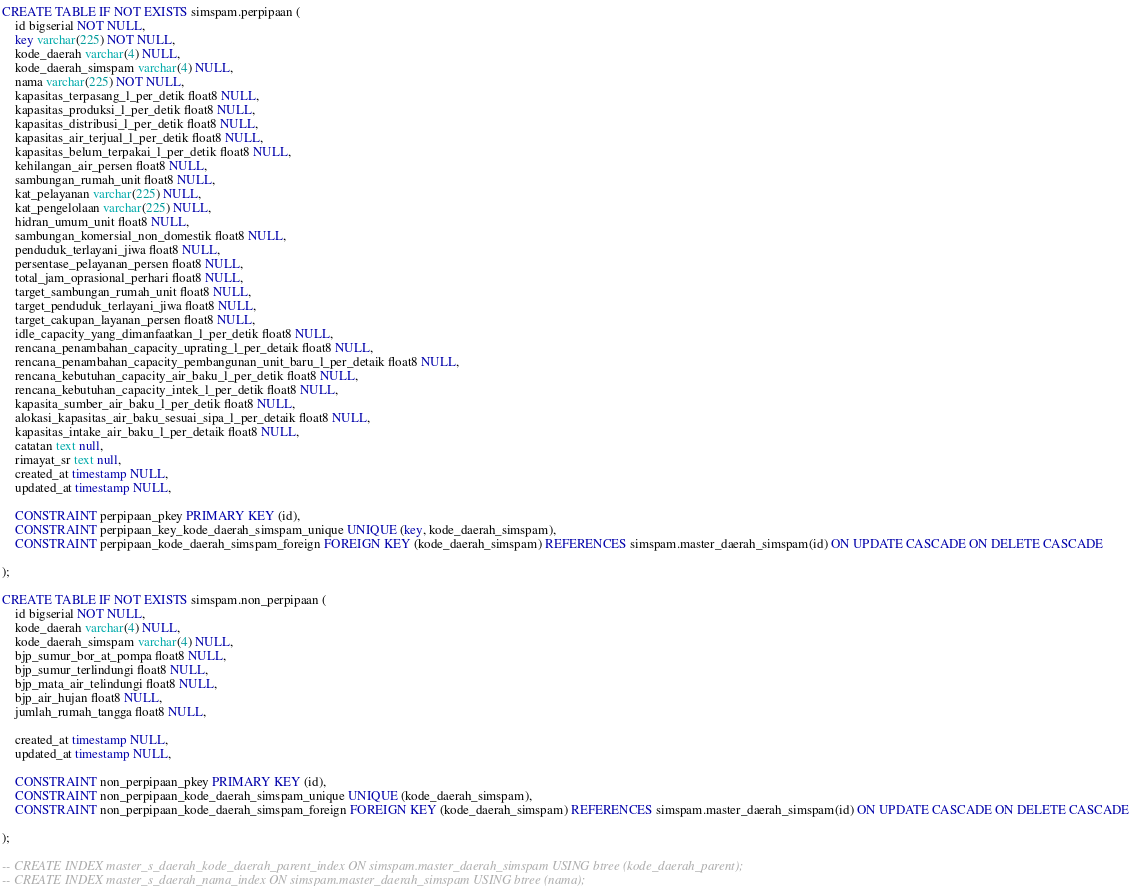<code> <loc_0><loc_0><loc_500><loc_500><_SQL_>

CREATE TABLE IF NOT EXISTS simspam.perpipaan (
	id bigserial NOT NULL,
	key varchar(225) NOT NULL,
	kode_daerah varchar(4) NULL,
	kode_daerah_simspam varchar(4) NULL,
	nama varchar(225) NOT NULL,
	kapasitas_terpasang_l_per_detik float8 NULL,
	kapasitas_produksi_l_per_detik float8 NULL,
	kapasitas_distribusi_l_per_detik float8 NULL,
	kapasitas_air_terjual_l_per_detik float8 NULL,
	kapasitas_belum_terpakai_l_per_detik float8 NULL,
	kehilangan_air_persen float8 NULL,
	sambungan_rumah_unit float8 NULL,
	kat_pelayanan varchar(225) NULL,
	kat_pengelolaan varchar(225) NULL,
	hidran_umum_unit float8 NULL,
	sambungan_komersial_non_domestik float8 NULL,
	penduduk_terlayani_jiwa float8 NULL,
	persentase_pelayanan_persen float8 NULL,
	total_jam_oprasional_perhari float8 NULL,
	target_sambungan_rumah_unit float8 NULL,
	target_penduduk_terlayani_jiwa float8 NULL,
	target_cakupan_layanan_persen float8 NULL,
	idle_capacity_yang_dimanfaatkan_l_per_detik float8 NULL,
	rencana_penambahan_capacity_uprating_l_per_detaik float8 NULL,
	rencana_penambahan_capacity_pembangunan_unit_baru_l_per_detaik float8 NULL,
	rencana_kebutuhan_capacity_air_baku_l_per_detik float8 NULL,
	rencana_kebutuhan_capacity_intek_l_per_detik float8 NULL,
	kapasita_sumber_air_baku_l_per_detik float8 NULL,
	alokasi_kapasitas_air_baku_sesuai_sipa_l_per_detaik float8 NULL,
	kapasitas_intake_air_baku_l_per_detaik float8 NULL,
	catatan text null,
	rimayat_sr text null,
	created_at timestamp NULL,
	updated_at timestamp NULL,

	CONSTRAINT perpipaan_pkey PRIMARY KEY (id),
	CONSTRAINT perpipaan_key_kode_daerah_simspam_unique UNIQUE (key, kode_daerah_simspam),
	CONSTRAINT perpipaan_kode_daerah_simspam_foreign FOREIGN KEY (kode_daerah_simspam) REFERENCES simspam.master_daerah_simspam(id) ON UPDATE CASCADE ON DELETE CASCADE

);

CREATE TABLE IF NOT EXISTS simspam.non_perpipaan (
	id bigserial NOT NULL,
	kode_daerah varchar(4) NULL,
	kode_daerah_simspam varchar(4) NULL,
	bjp_sumur_bor_at_pompa float8 NULL,
	bjp_sumur_terlindungi float8 NULL,
	bjp_mata_air_telindungi float8 NULL,
	bjp_air_hujan float8 NULL,
	jumlah_rumah_tangga float8 NULL,
	
	created_at timestamp NULL,
	updated_at timestamp NULL,

	CONSTRAINT non_perpipaan_pkey PRIMARY KEY (id),
	CONSTRAINT non_perpipaan_kode_daerah_simspam_unique UNIQUE (kode_daerah_simspam),
	CONSTRAINT non_perpipaan_kode_daerah_simspam_foreign FOREIGN KEY (kode_daerah_simspam) REFERENCES simspam.master_daerah_simspam(id) ON UPDATE CASCADE ON DELETE CASCADE

);

-- CREATE INDEX master_s_daerah_kode_daerah_parent_index ON simspam.master_daerah_simspam USING btree (kode_daerah_parent);
-- CREATE INDEX master_s_daerah_nama_index ON simspam.master_daerah_simspam USING btree (nama);</code> 